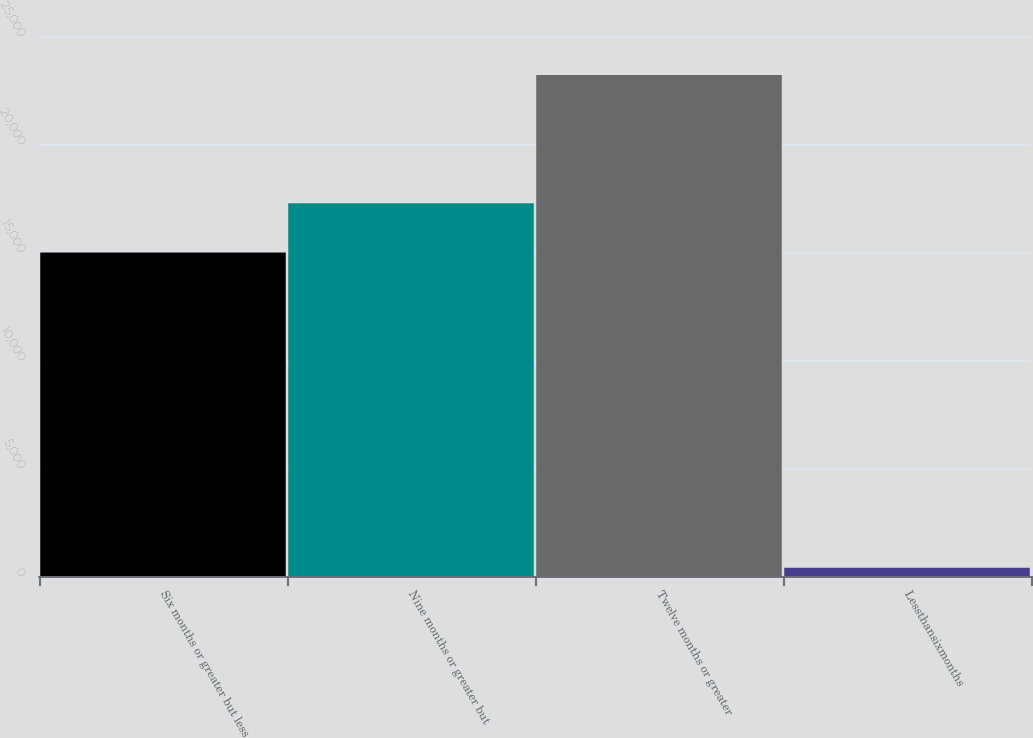Convert chart to OTSL. <chart><loc_0><loc_0><loc_500><loc_500><bar_chart><fcel>Six months or greater but less<fcel>Nine months or greater but<fcel>Twelve months or greater<fcel>Lessthansixmonths<nl><fcel>14975<fcel>17255.5<fcel>23191<fcel>386<nl></chart> 